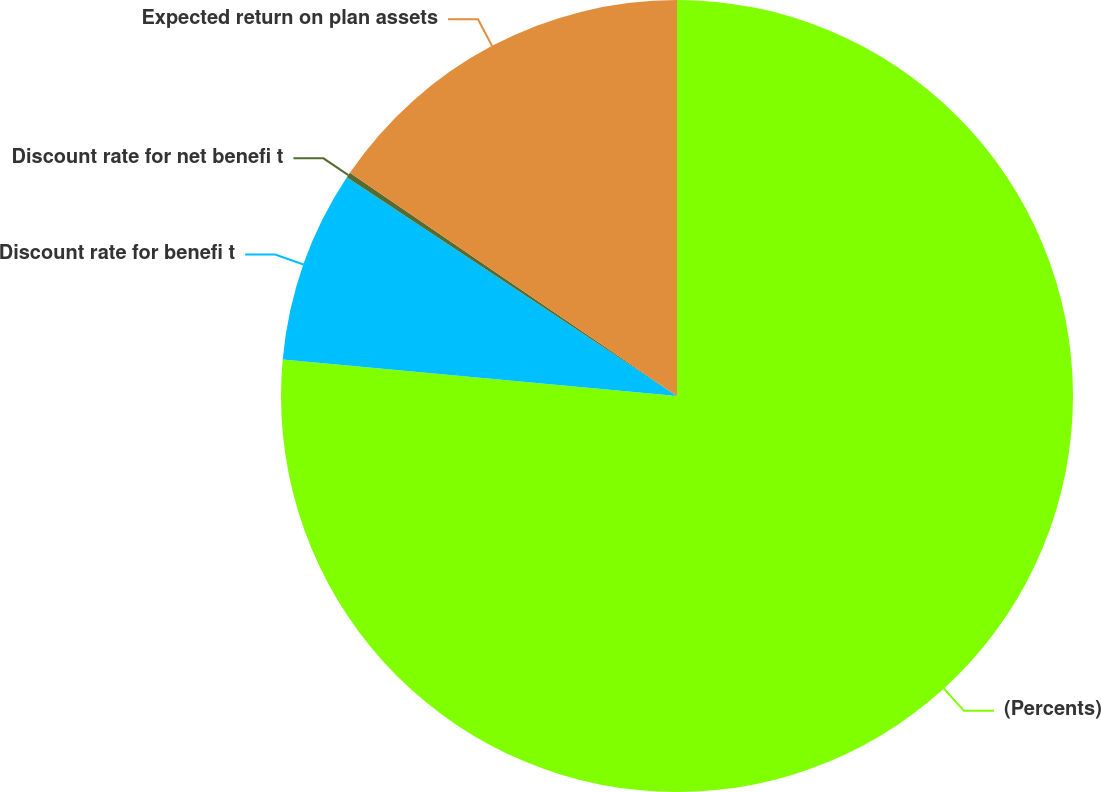<chart> <loc_0><loc_0><loc_500><loc_500><pie_chart><fcel>(Percents)<fcel>Discount rate for benefi t<fcel>Discount rate for net benefi t<fcel>Expected return on plan assets<nl><fcel>76.47%<fcel>7.84%<fcel>0.22%<fcel>15.47%<nl></chart> 